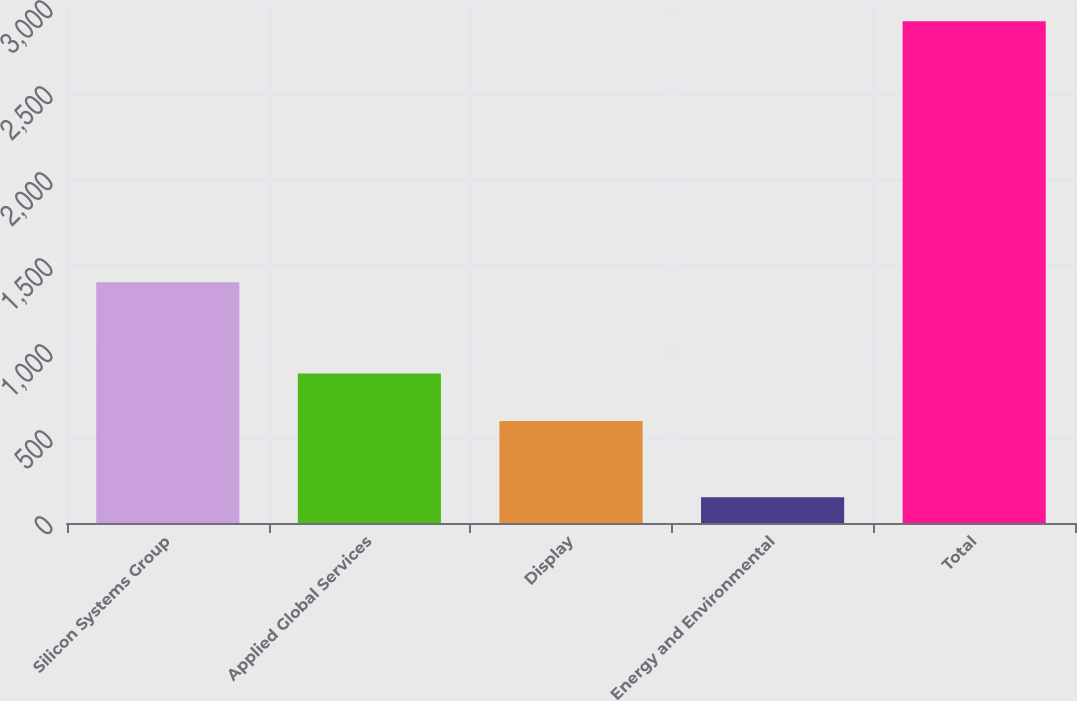Convert chart to OTSL. <chart><loc_0><loc_0><loc_500><loc_500><bar_chart><fcel>Silicon Systems Group<fcel>Applied Global Services<fcel>Display<fcel>Energy and Environmental<fcel>Total<nl><fcel>1400<fcel>869.8<fcel>593<fcel>149<fcel>2917<nl></chart> 